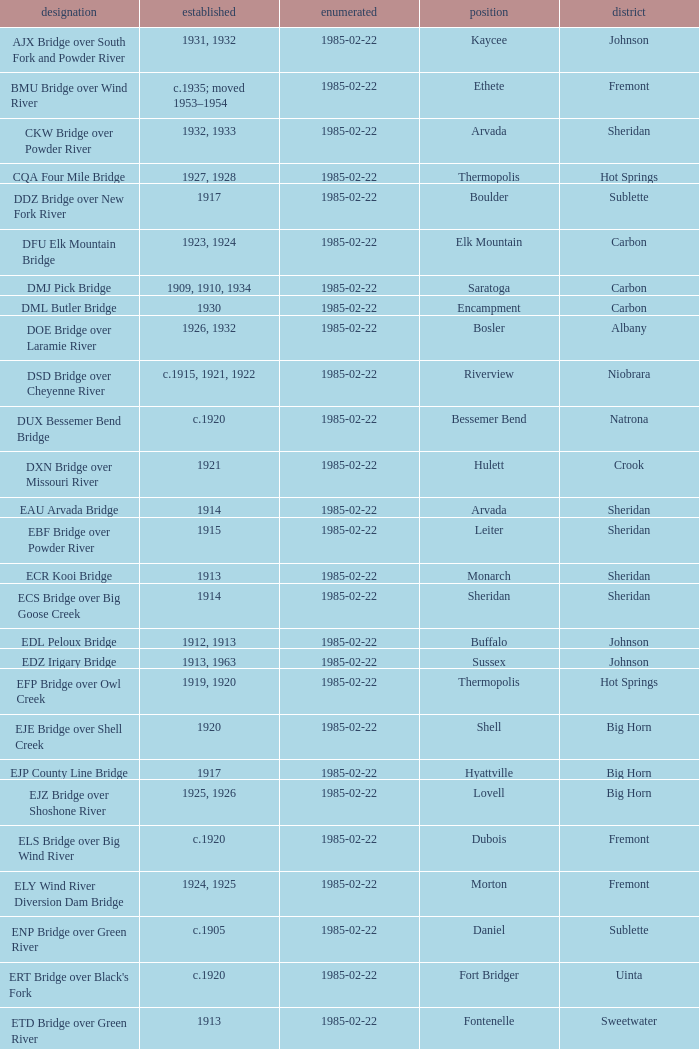Which bridge constructed in 1915 is located in sheridan county? EBF Bridge over Powder River. Could you parse the entire table as a dict? {'header': ['designation', 'established', 'enumerated', 'position', 'district'], 'rows': [['AJX Bridge over South Fork and Powder River', '1931, 1932', '1985-02-22', 'Kaycee', 'Johnson'], ['BMU Bridge over Wind River', 'c.1935; moved 1953–1954', '1985-02-22', 'Ethete', 'Fremont'], ['CKW Bridge over Powder River', '1932, 1933', '1985-02-22', 'Arvada', 'Sheridan'], ['CQA Four Mile Bridge', '1927, 1928', '1985-02-22', 'Thermopolis', 'Hot Springs'], ['DDZ Bridge over New Fork River', '1917', '1985-02-22', 'Boulder', 'Sublette'], ['DFU Elk Mountain Bridge', '1923, 1924', '1985-02-22', 'Elk Mountain', 'Carbon'], ['DMJ Pick Bridge', '1909, 1910, 1934', '1985-02-22', 'Saratoga', 'Carbon'], ['DML Butler Bridge', '1930', '1985-02-22', 'Encampment', 'Carbon'], ['DOE Bridge over Laramie River', '1926, 1932', '1985-02-22', 'Bosler', 'Albany'], ['DSD Bridge over Cheyenne River', 'c.1915, 1921, 1922', '1985-02-22', 'Riverview', 'Niobrara'], ['DUX Bessemer Bend Bridge', 'c.1920', '1985-02-22', 'Bessemer Bend', 'Natrona'], ['DXN Bridge over Missouri River', '1921', '1985-02-22', 'Hulett', 'Crook'], ['EAU Arvada Bridge', '1914', '1985-02-22', 'Arvada', 'Sheridan'], ['EBF Bridge over Powder River', '1915', '1985-02-22', 'Leiter', 'Sheridan'], ['ECR Kooi Bridge', '1913', '1985-02-22', 'Monarch', 'Sheridan'], ['ECS Bridge over Big Goose Creek', '1914', '1985-02-22', 'Sheridan', 'Sheridan'], ['EDL Peloux Bridge', '1912, 1913', '1985-02-22', 'Buffalo', 'Johnson'], ['EDZ Irigary Bridge', '1913, 1963', '1985-02-22', 'Sussex', 'Johnson'], ['EFP Bridge over Owl Creek', '1919, 1920', '1985-02-22', 'Thermopolis', 'Hot Springs'], ['EJE Bridge over Shell Creek', '1920', '1985-02-22', 'Shell', 'Big Horn'], ['EJP County Line Bridge', '1917', '1985-02-22', 'Hyattville', 'Big Horn'], ['EJZ Bridge over Shoshone River', '1925, 1926', '1985-02-22', 'Lovell', 'Big Horn'], ['ELS Bridge over Big Wind River', 'c.1920', '1985-02-22', 'Dubois', 'Fremont'], ['ELY Wind River Diversion Dam Bridge', '1924, 1925', '1985-02-22', 'Morton', 'Fremont'], ['ENP Bridge over Green River', 'c.1905', '1985-02-22', 'Daniel', 'Sublette'], ["ERT Bridge over Black's Fork", 'c.1920', '1985-02-22', 'Fort Bridger', 'Uinta'], ['ETD Bridge over Green River', '1913', '1985-02-22', 'Fontenelle', 'Sweetwater'], ['ETR Big Island Bridge', '1909, 1910', '1985-02-22', 'Green River', 'Sweetwater'], ['EWZ Bridge over East Channel of Laramie River', '1913, 1914', '1985-02-22', 'Wheatland', 'Platte'], ['Hayden Arch Bridge', '1924, 1925', '1985-02-22', 'Cody', 'Park'], ['Rairden Bridge', '1916', '1985-02-22', 'Manderson', 'Big Horn']]} 